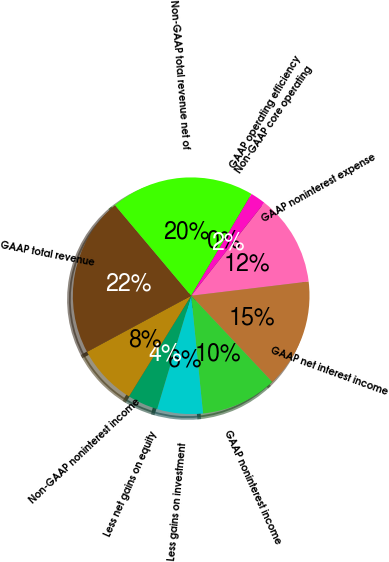<chart> <loc_0><loc_0><loc_500><loc_500><pie_chart><fcel>GAAP noninterest expense<fcel>GAAP net interest income<fcel>GAAP noninterest income<fcel>Less gains on investment<fcel>Less net gains on equity<fcel>Non-GAAP noninterest income<fcel>GAAP total revenue<fcel>Non-GAAP total revenue net of<fcel>GAAP operating efficiency<fcel>Non-GAAP core operating<nl><fcel>12.49%<fcel>14.9%<fcel>10.41%<fcel>6.24%<fcel>4.16%<fcel>8.33%<fcel>21.73%<fcel>19.65%<fcel>0.0%<fcel>2.08%<nl></chart> 